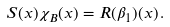Convert formula to latex. <formula><loc_0><loc_0><loc_500><loc_500>S ( x ) \chi _ { B } ( x ) = R ( \beta _ { 1 } ) ( x ) \, .</formula> 